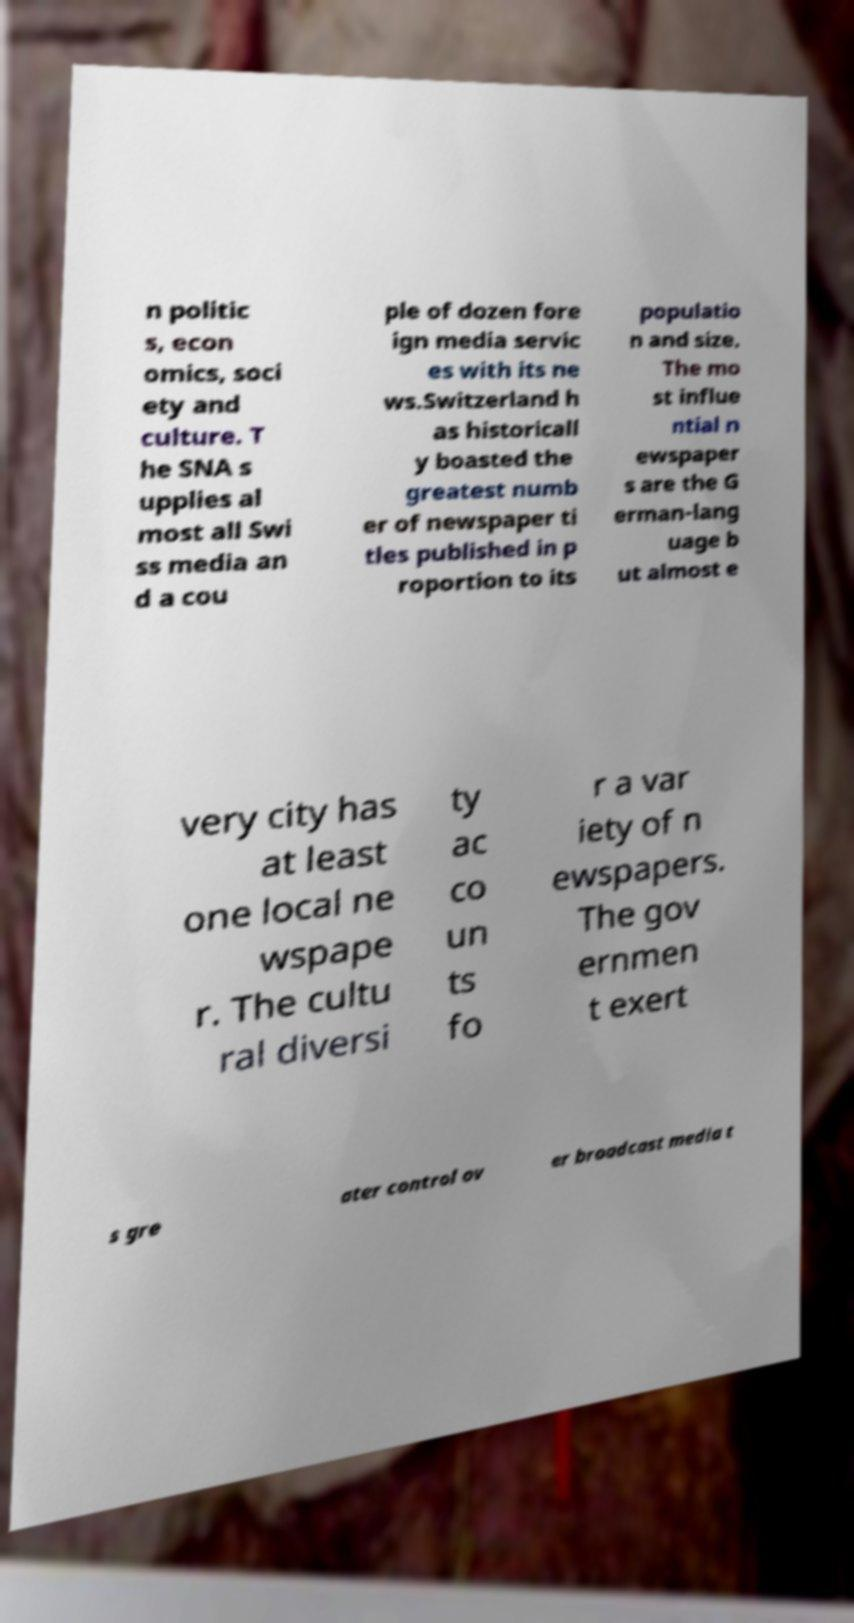Please read and relay the text visible in this image. What does it say? n politic s, econ omics, soci ety and culture. T he SNA s upplies al most all Swi ss media an d a cou ple of dozen fore ign media servic es with its ne ws.Switzerland h as historicall y boasted the greatest numb er of newspaper ti tles published in p roportion to its populatio n and size. The mo st influe ntial n ewspaper s are the G erman-lang uage b ut almost e very city has at least one local ne wspape r. The cultu ral diversi ty ac co un ts fo r a var iety of n ewspapers. The gov ernmen t exert s gre ater control ov er broadcast media t 